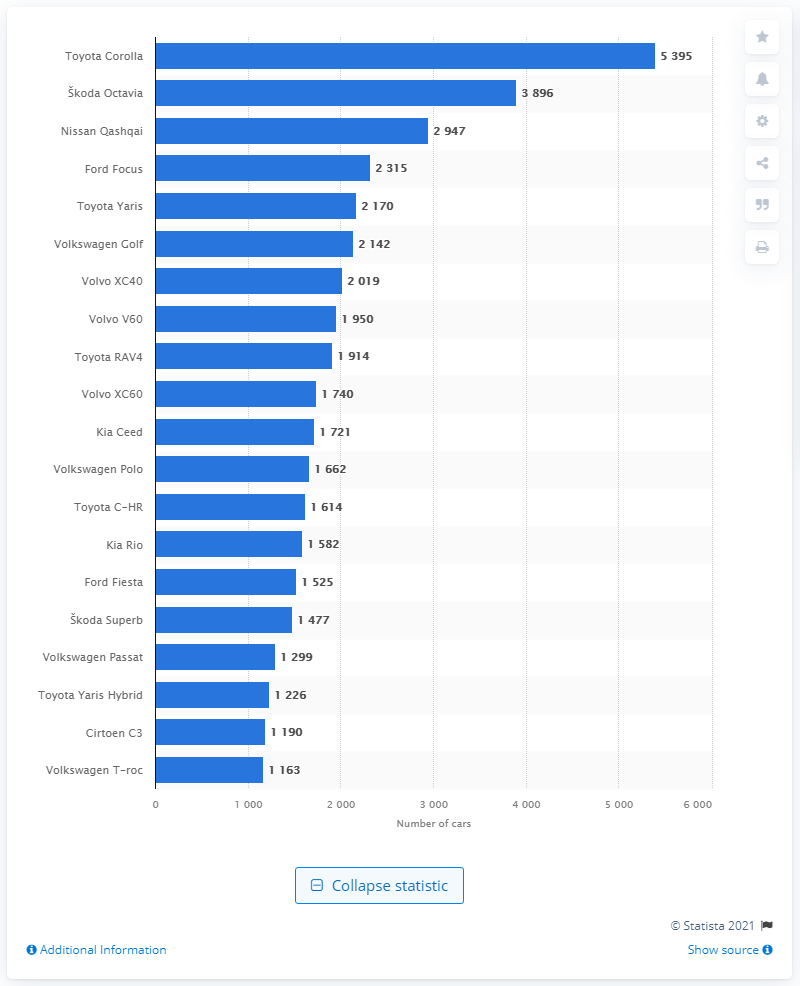Specify some key components in this picture. In 2020, a total of 5,395 new Toyota Corolla vehicles were registered in Finland. 